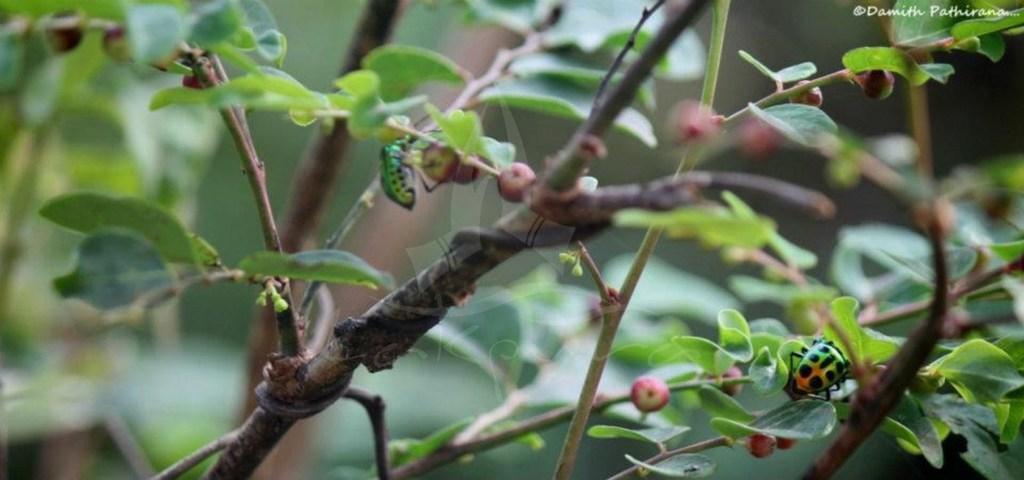In one or two sentences, can you explain what this image depicts? In this image we can see files which are on branches of plants and there are some leaves and fruits. 